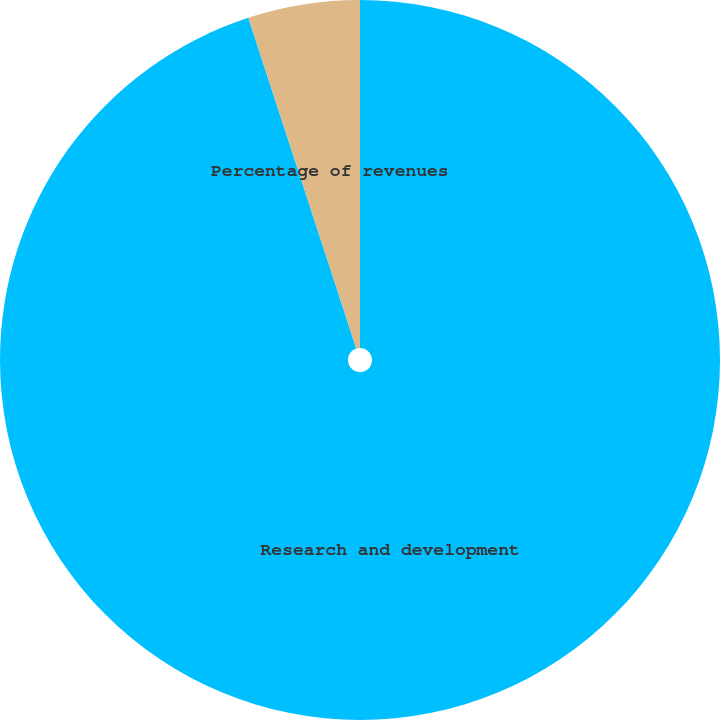<chart> <loc_0><loc_0><loc_500><loc_500><pie_chart><fcel>Research and development<fcel>Percentage of revenues<nl><fcel>94.98%<fcel>5.02%<nl></chart> 